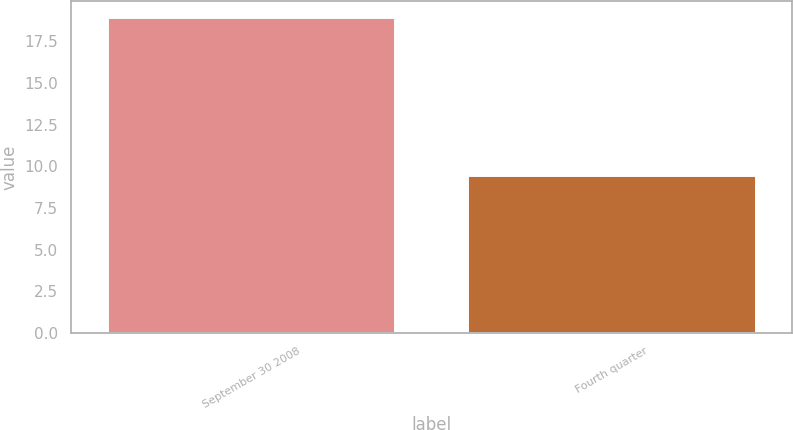Convert chart. <chart><loc_0><loc_0><loc_500><loc_500><bar_chart><fcel>September 30 2008<fcel>Fourth quarter<nl><fcel>18.96<fcel>9.5<nl></chart> 